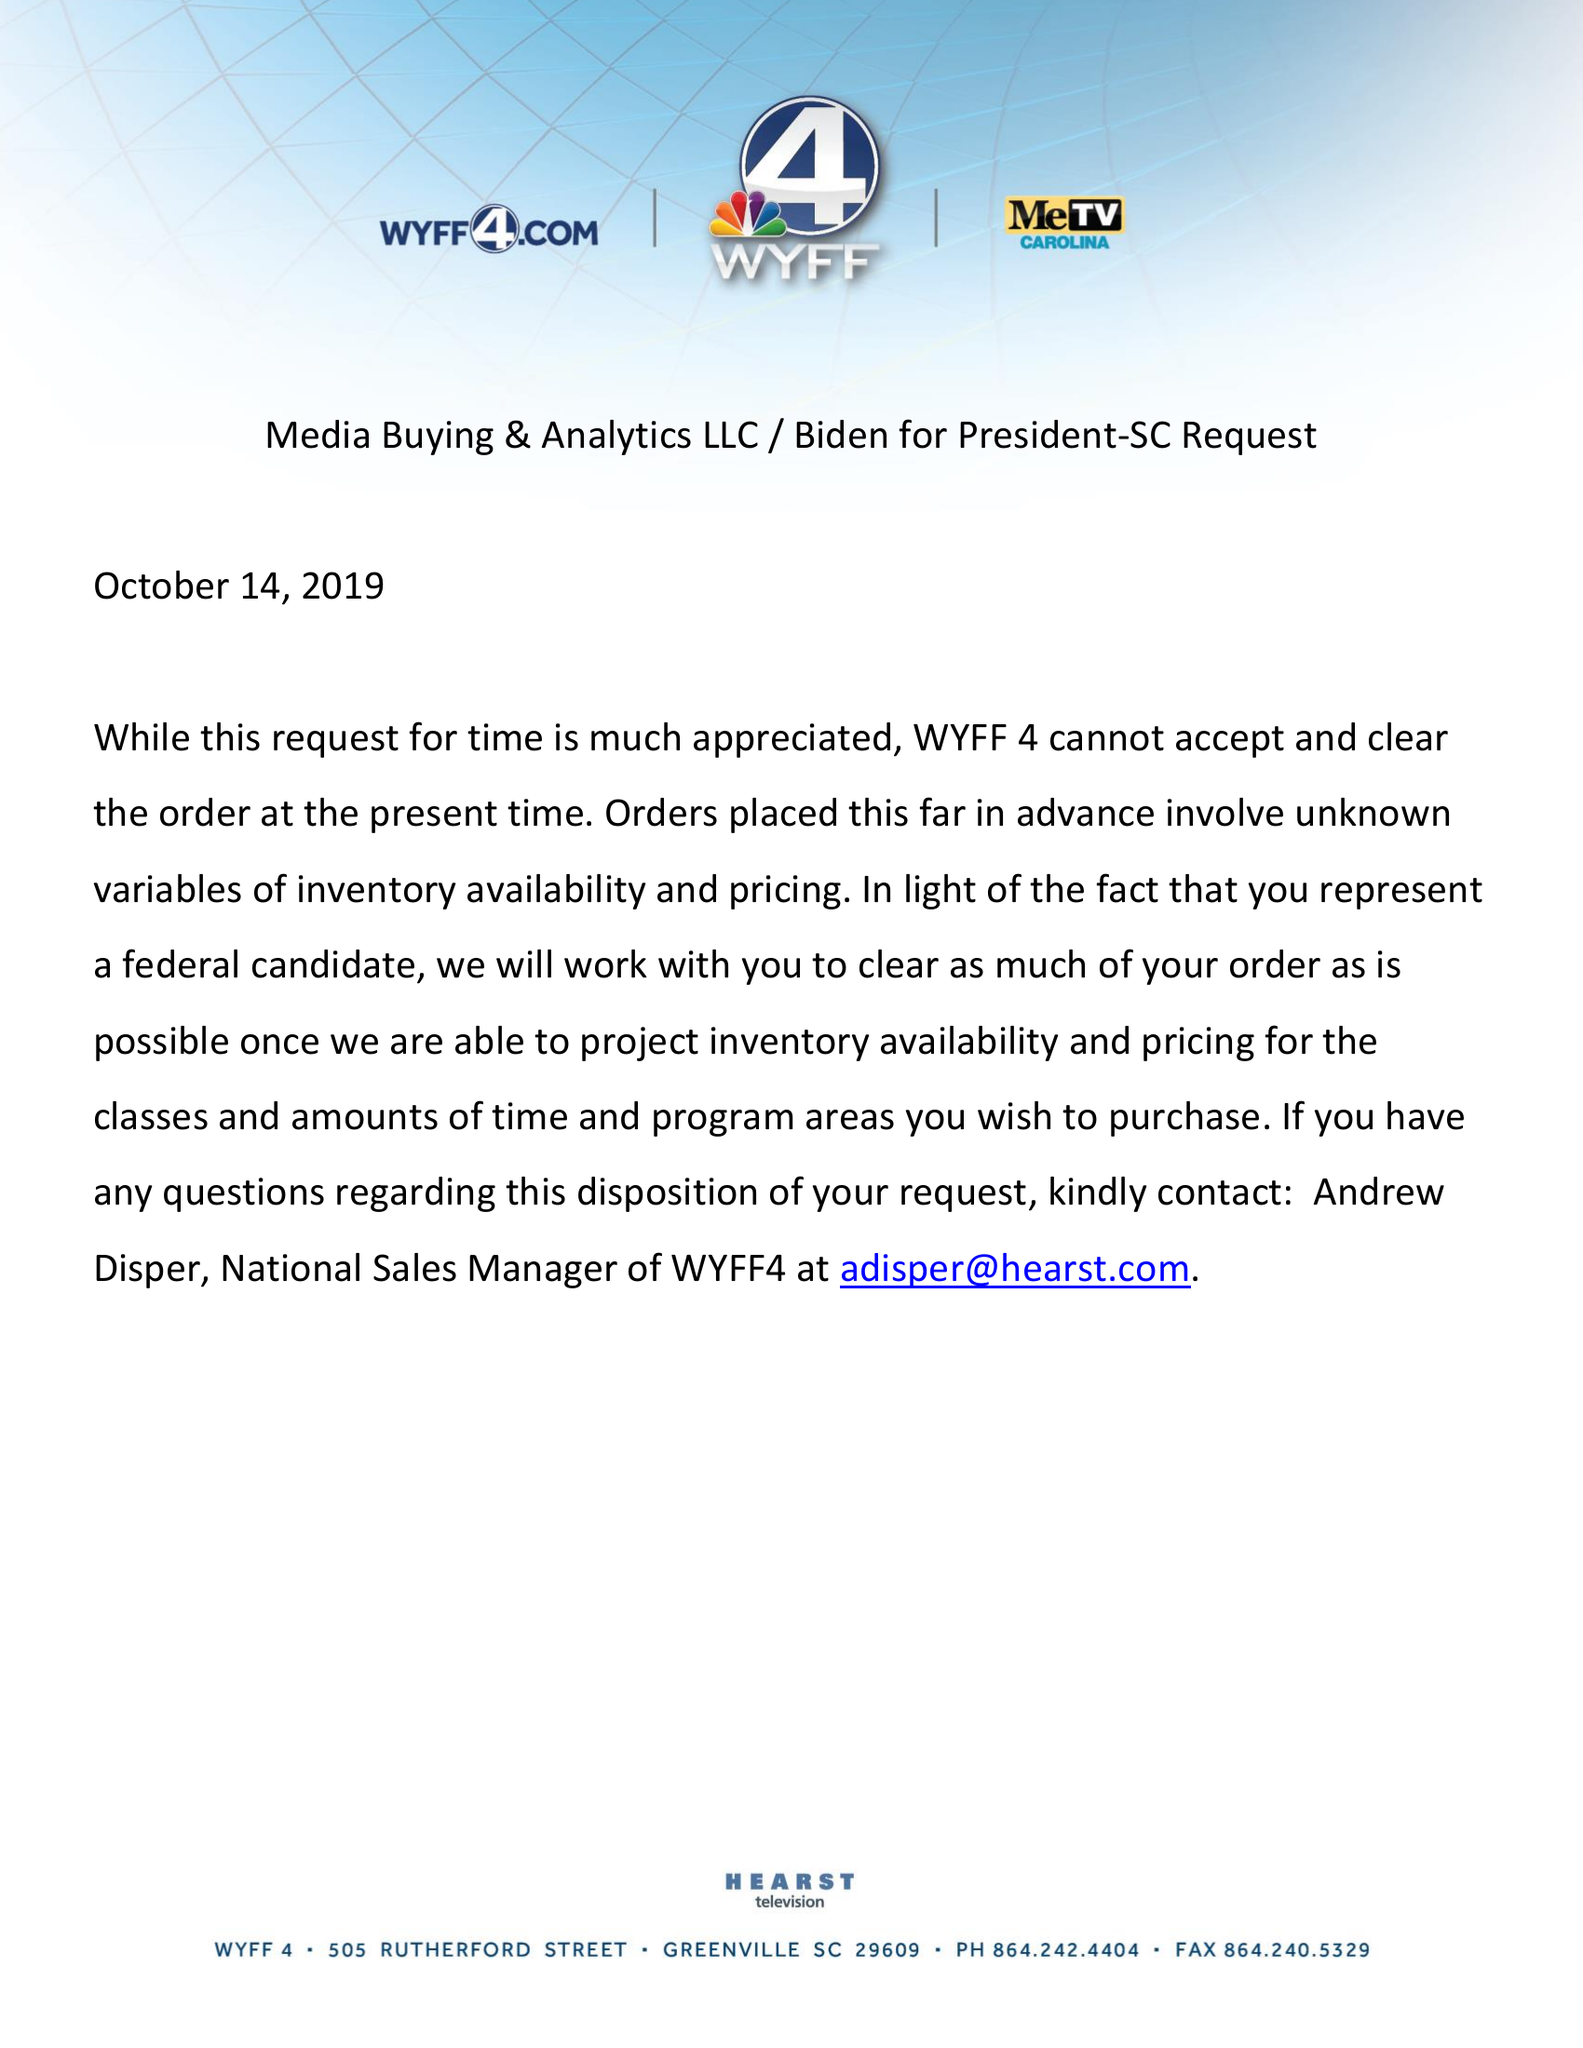What is the value for the flight_to?
Answer the question using a single word or phrase. None 